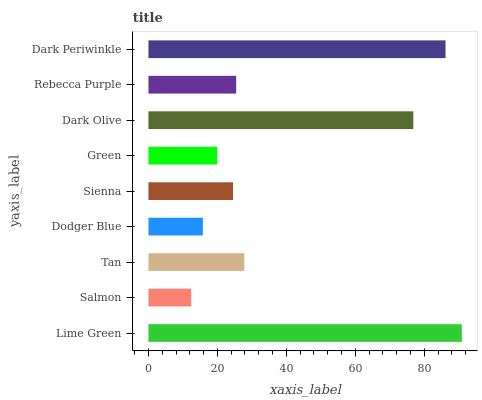Is Salmon the minimum?
Answer yes or no. Yes. Is Lime Green the maximum?
Answer yes or no. Yes. Is Tan the minimum?
Answer yes or no. No. Is Tan the maximum?
Answer yes or no. No. Is Tan greater than Salmon?
Answer yes or no. Yes. Is Salmon less than Tan?
Answer yes or no. Yes. Is Salmon greater than Tan?
Answer yes or no. No. Is Tan less than Salmon?
Answer yes or no. No. Is Rebecca Purple the high median?
Answer yes or no. Yes. Is Rebecca Purple the low median?
Answer yes or no. Yes. Is Green the high median?
Answer yes or no. No. Is Green the low median?
Answer yes or no. No. 